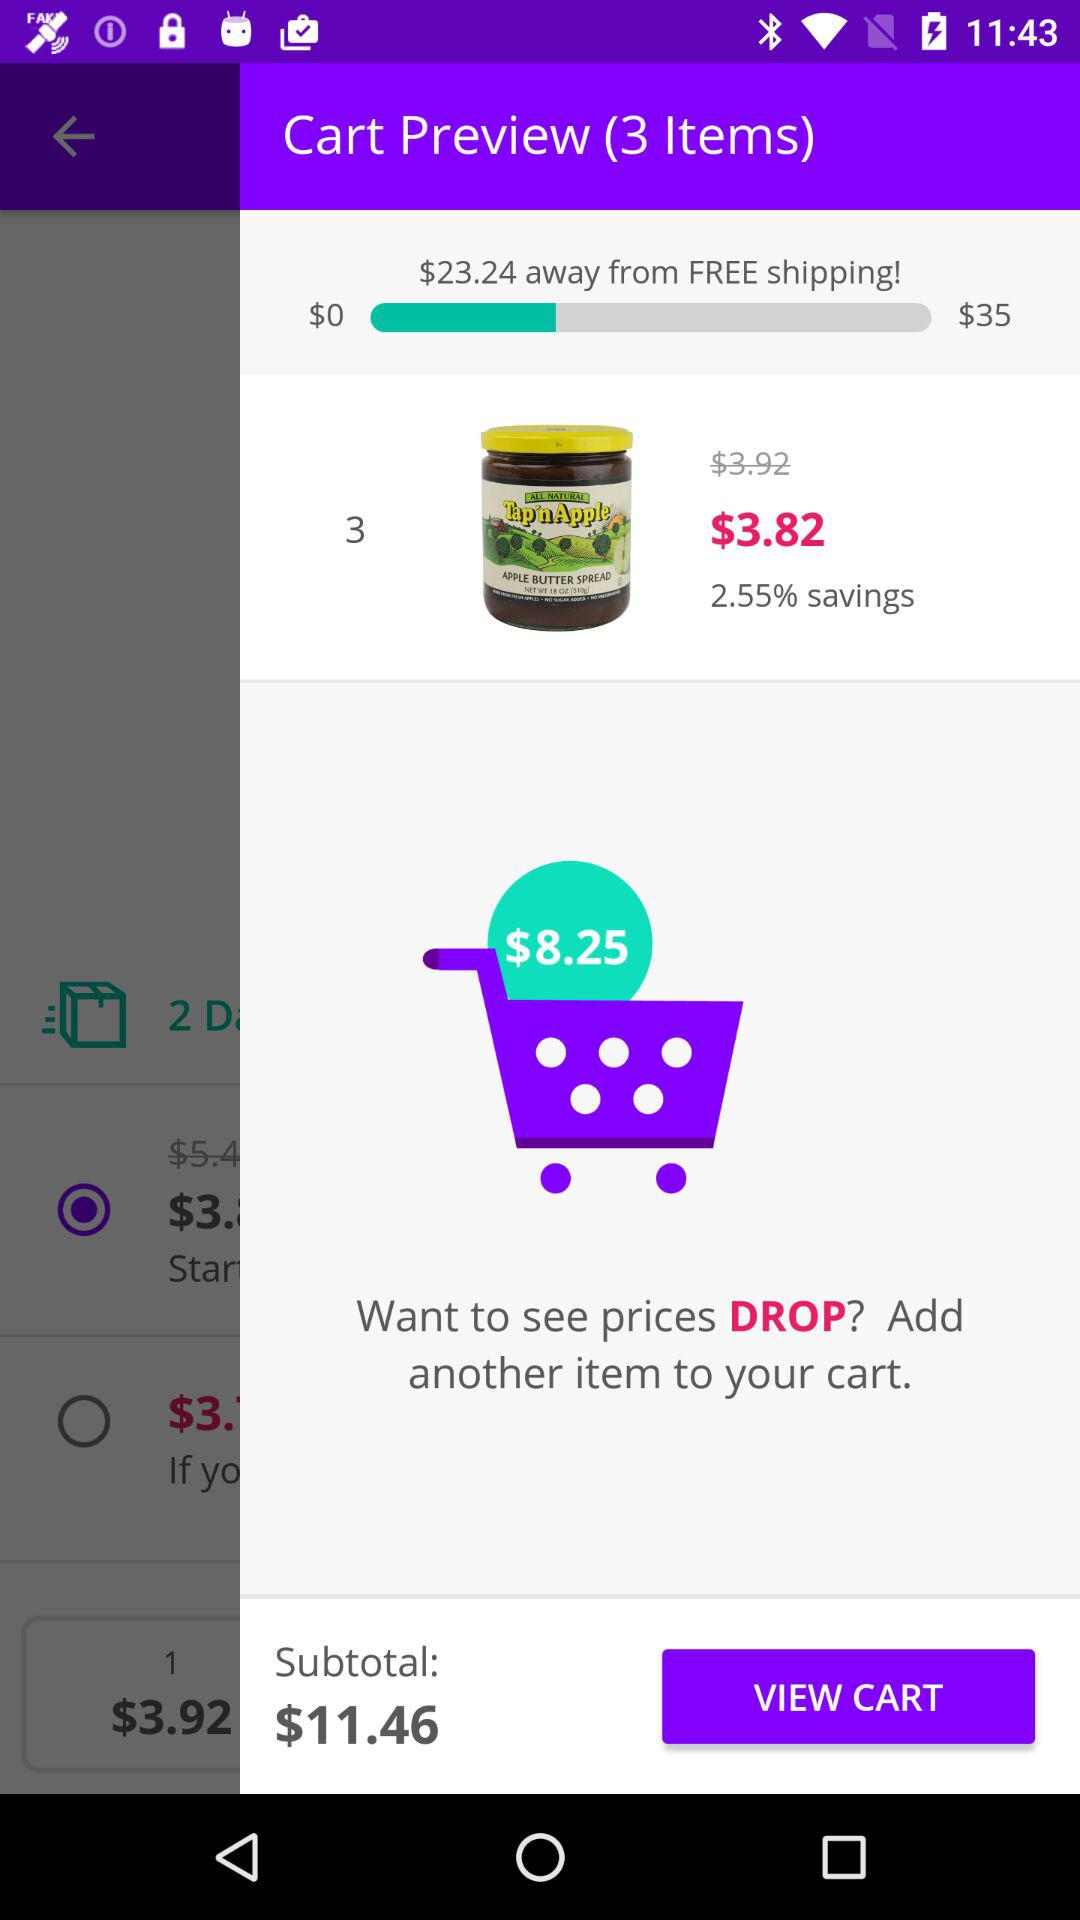How much more do I need to spend to get free shipping?
Answer the question using a single word or phrase. $23.24 